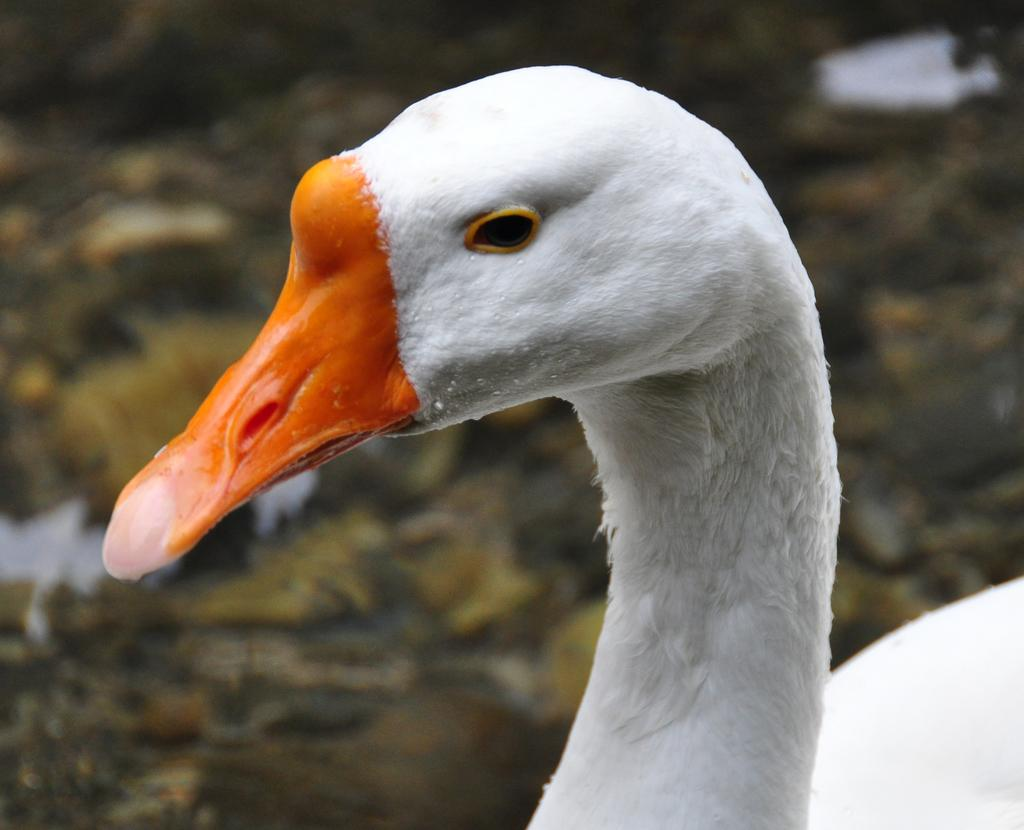What type of animal is in the image? There is a swan in the image. What is the color of the swan? The swan is white in color. What color is the swan's beak? The swan's beak is orange in color. How many balls can be seen hanging from the tree in the image? There is no tree or balls present in the image; it features a swan. 